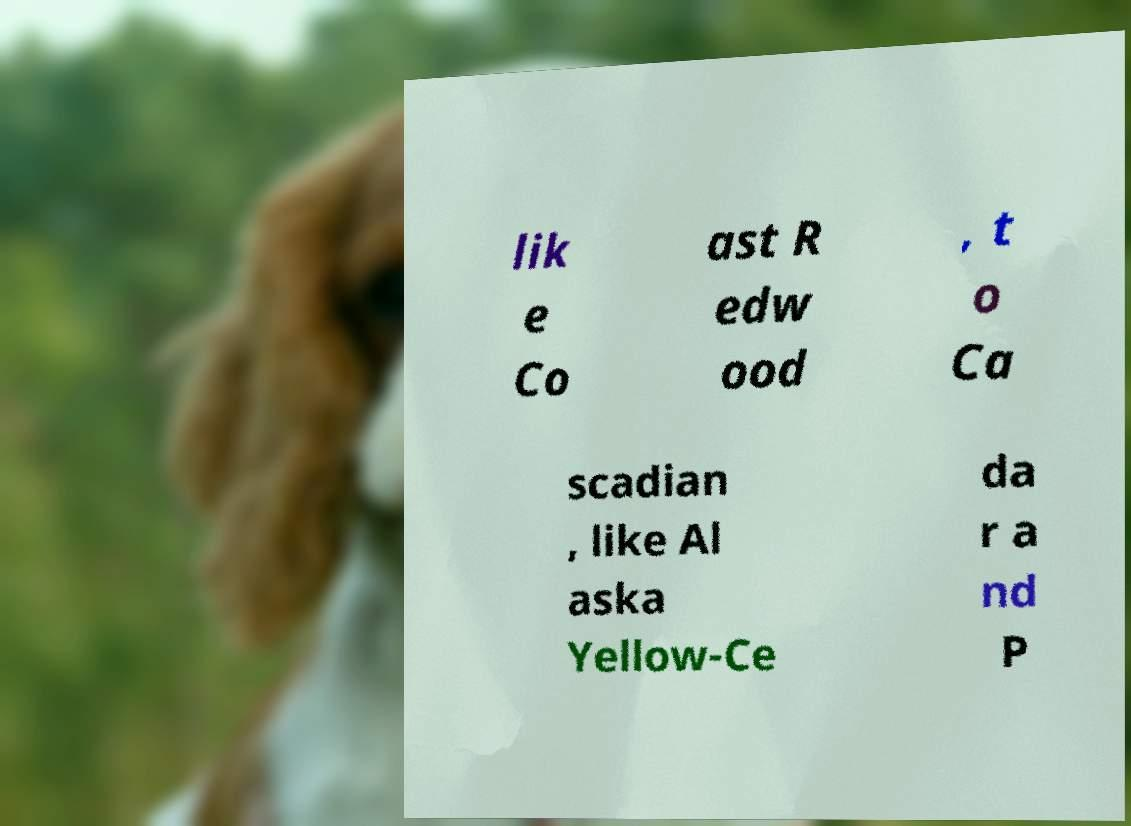Please read and relay the text visible in this image. What does it say? lik e Co ast R edw ood , t o Ca scadian , like Al aska Yellow-Ce da r a nd P 